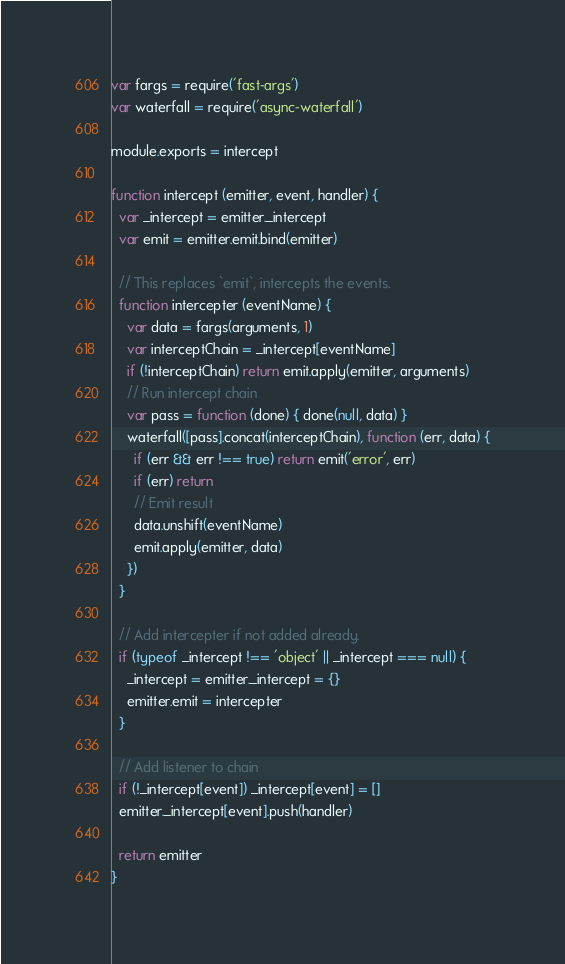<code> <loc_0><loc_0><loc_500><loc_500><_JavaScript_>var fargs = require('fast-args')
var waterfall = require('async-waterfall')

module.exports = intercept

function intercept (emitter, event, handler) {
  var _intercept = emitter._intercept
  var emit = emitter.emit.bind(emitter)

  // This replaces `emit`, intercepts the events.
  function intercepter (eventName) {
    var data = fargs(arguments, 1)
    var interceptChain = _intercept[eventName]
    if (!interceptChain) return emit.apply(emitter, arguments)
    // Run intercept chain
    var pass = function (done) { done(null, data) }
    waterfall([pass].concat(interceptChain), function (err, data) {
      if (err && err !== true) return emit('error', err)
      if (err) return
      // Emit result
      data.unshift(eventName)
      emit.apply(emitter, data)
    })
  }

  // Add intercepter if not added already.
  if (typeof _intercept !== 'object' || _intercept === null) {
    _intercept = emitter._intercept = {}
    emitter.emit = intercepter
  }

  // Add listener to chain
  if (!_intercept[event]) _intercept[event] = []
  emitter._intercept[event].push(handler)

  return emitter
}
</code> 